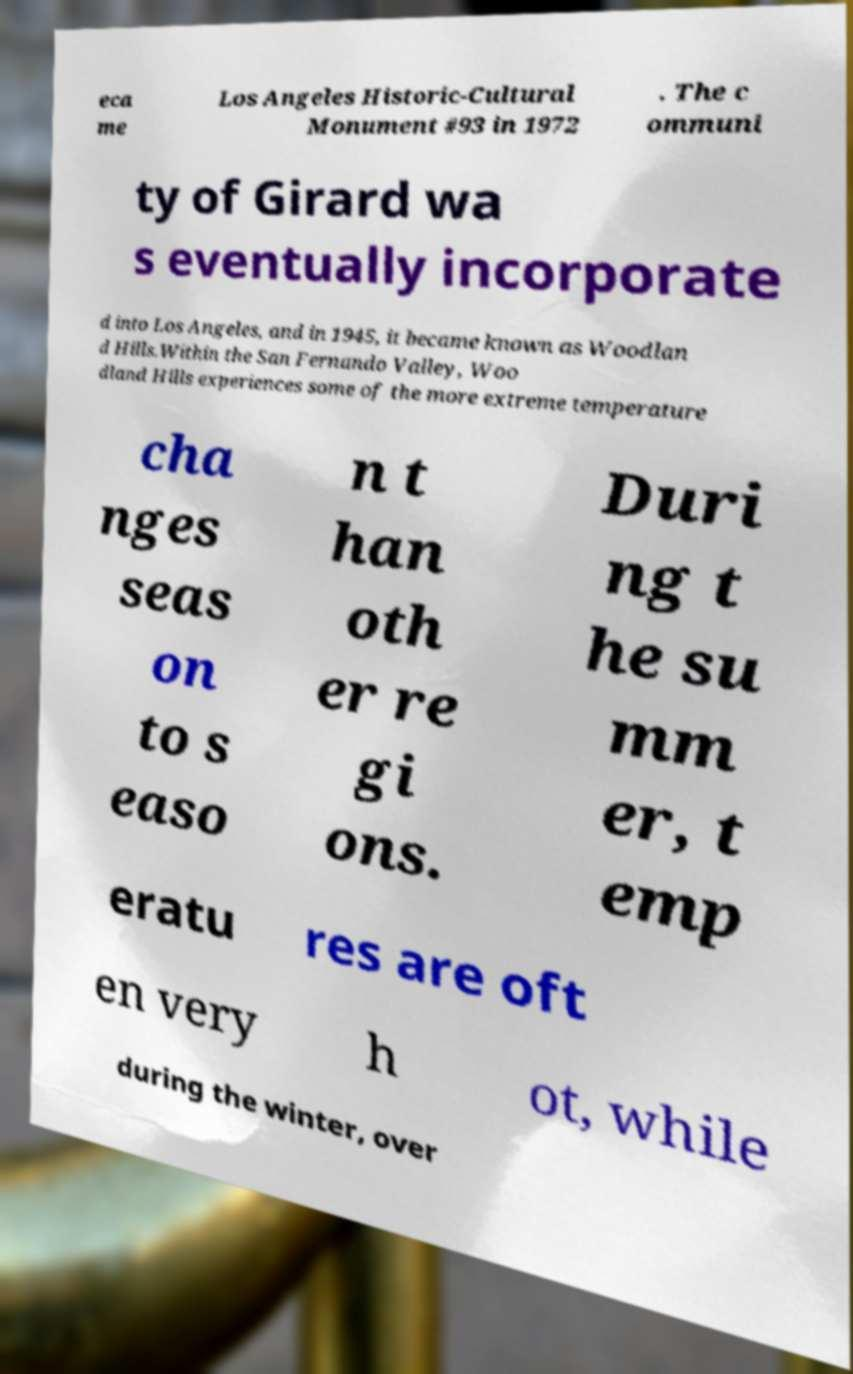I need the written content from this picture converted into text. Can you do that? eca me Los Angeles Historic-Cultural Monument #93 in 1972 . The c ommuni ty of Girard wa s eventually incorporate d into Los Angeles, and in 1945, it became known as Woodlan d Hills.Within the San Fernando Valley, Woo dland Hills experiences some of the more extreme temperature cha nges seas on to s easo n t han oth er re gi ons. Duri ng t he su mm er, t emp eratu res are oft en very h ot, while during the winter, over 